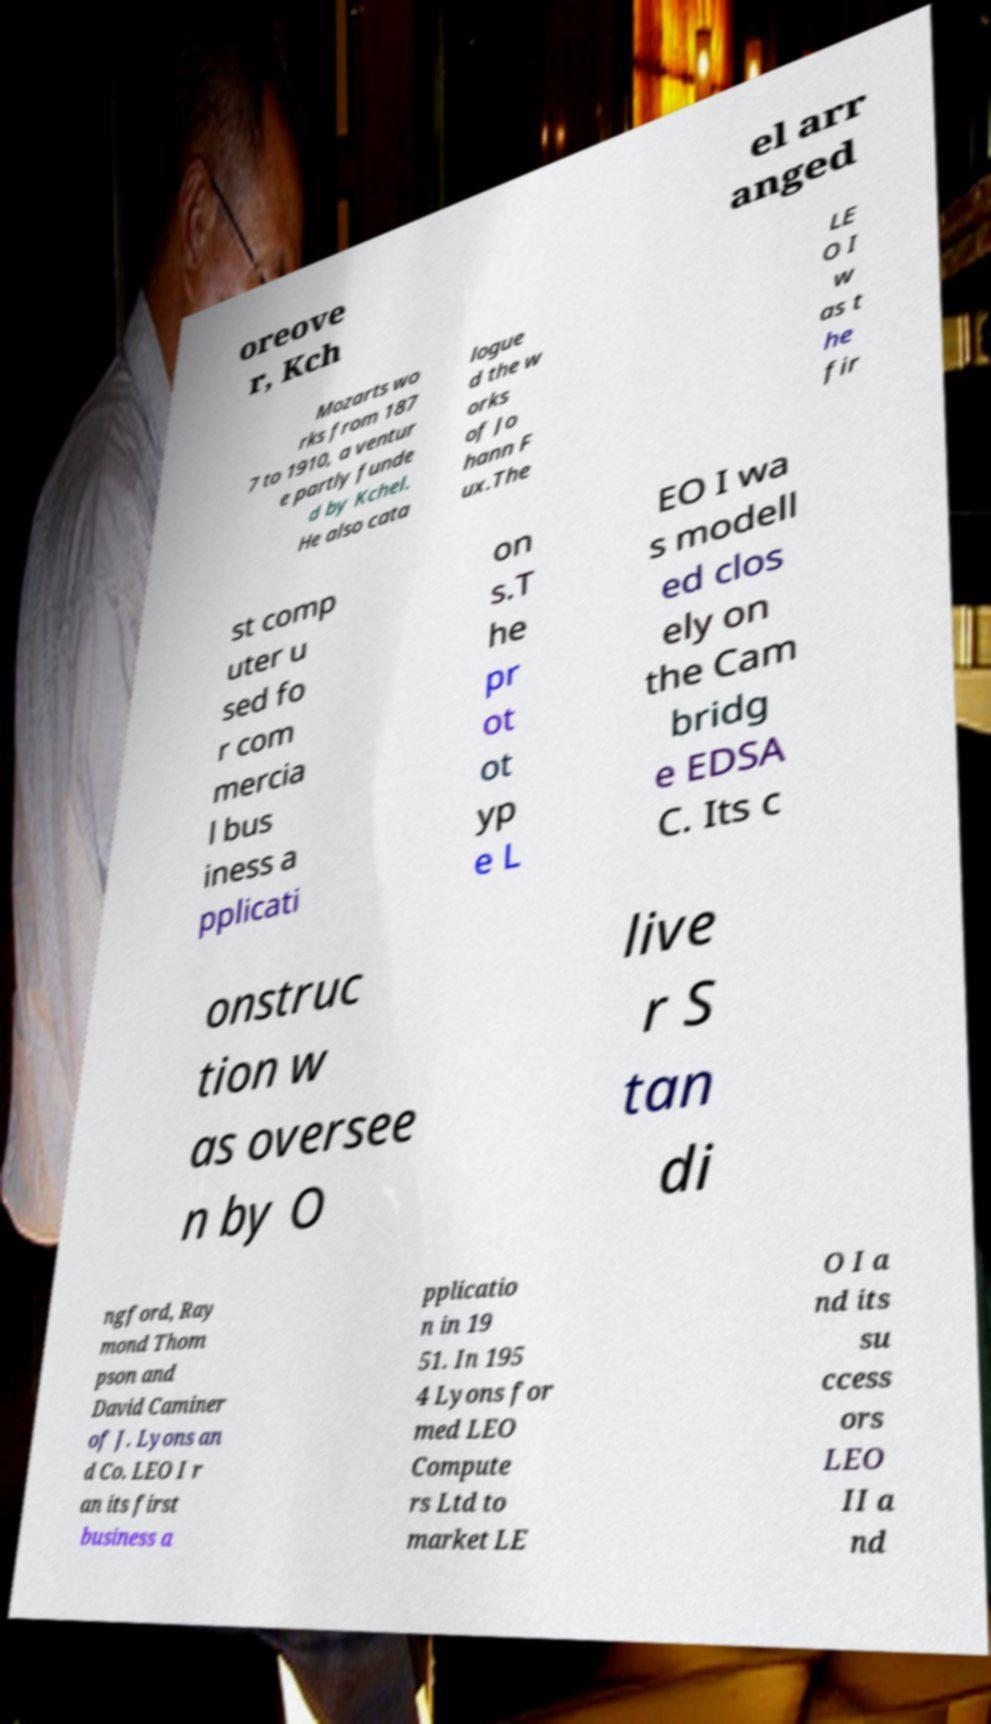I need the written content from this picture converted into text. Can you do that? oreove r, Kch el arr anged Mozarts wo rks from 187 7 to 1910, a ventur e partly funde d by Kchel. He also cata logue d the w orks of Jo hann F ux.The LE O I w as t he fir st comp uter u sed fo r com mercia l bus iness a pplicati on s.T he pr ot ot yp e L EO I wa s modell ed clos ely on the Cam bridg e EDSA C. Its c onstruc tion w as oversee n by O live r S tan di ngford, Ray mond Thom pson and David Caminer of J. Lyons an d Co. LEO I r an its first business a pplicatio n in 19 51. In 195 4 Lyons for med LEO Compute rs Ltd to market LE O I a nd its su ccess ors LEO II a nd 